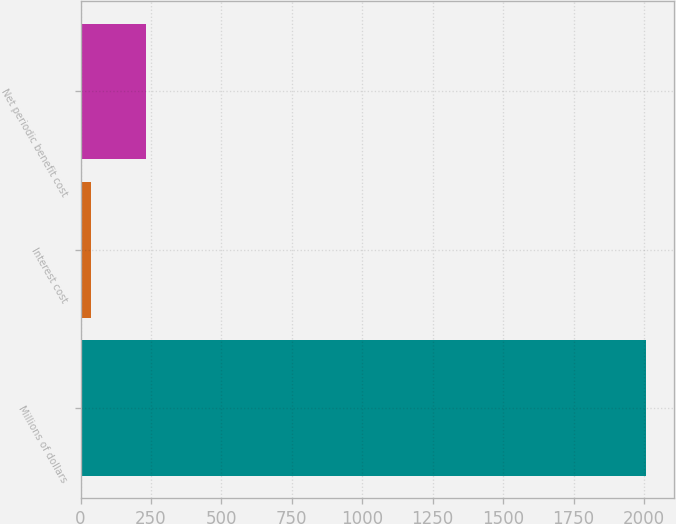Convert chart to OTSL. <chart><loc_0><loc_0><loc_500><loc_500><bar_chart><fcel>Millions of dollars<fcel>Interest cost<fcel>Net periodic benefit cost<nl><fcel>2006<fcel>37<fcel>233.9<nl></chart> 